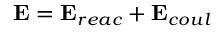<formula> <loc_0><loc_0><loc_500><loc_500>E = E _ { r e a c } + E _ { c o u l }</formula> 